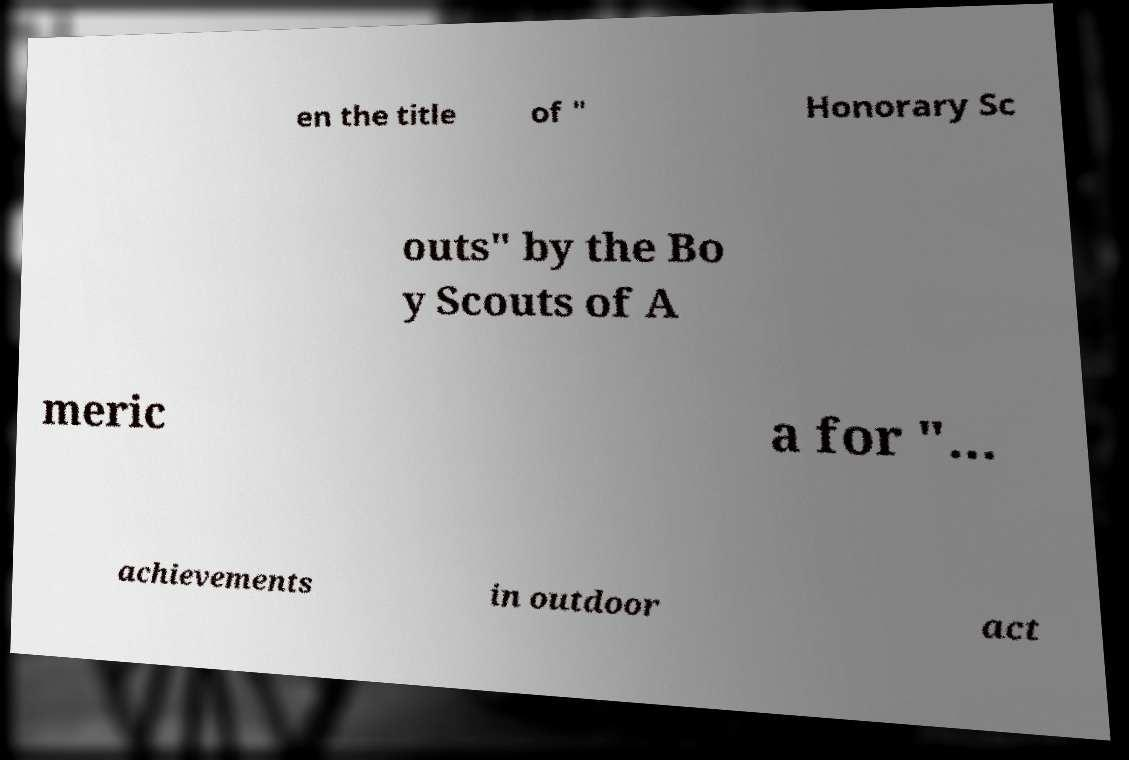Can you read and provide the text displayed in the image?This photo seems to have some interesting text. Can you extract and type it out for me? en the title of " Honorary Sc outs" by the Bo y Scouts of A meric a for "... achievements in outdoor act 